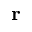<formula> <loc_0><loc_0><loc_500><loc_500>r</formula> 